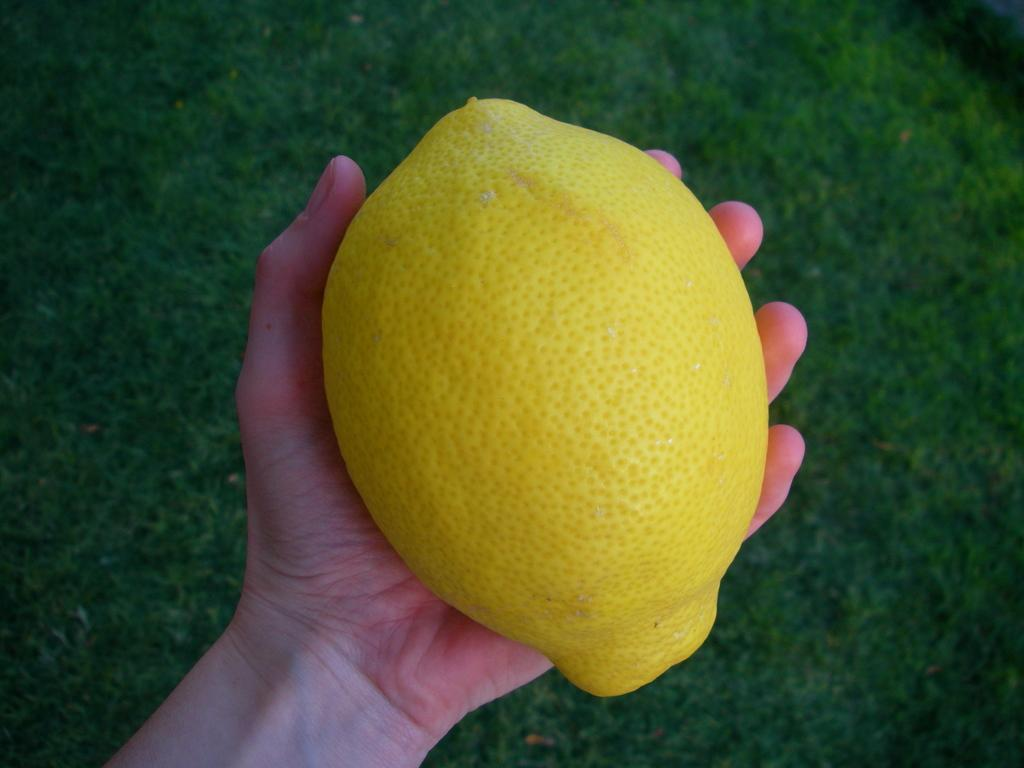Who or what is present in the image? There is a person in the image. What is the person holding in the image? The person is holding a lemon. What can be seen in the background of the image? There is grassland in the background of the image. What type of clover is growing in the bedroom in the image? There is no bedroom or clover present in the image. 